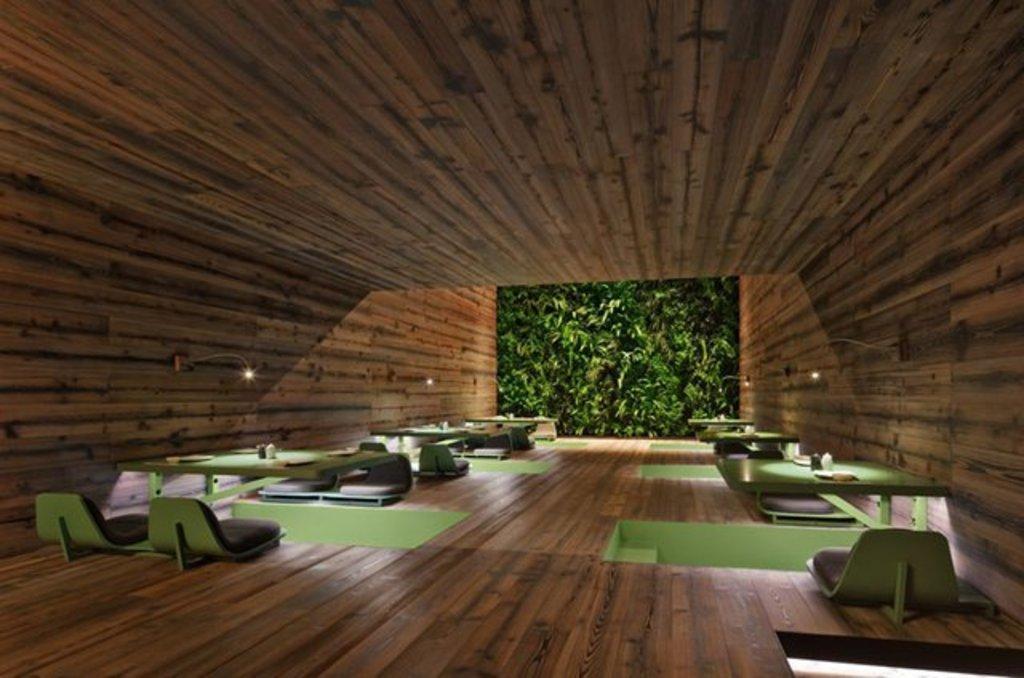How would you summarize this image in a sentence or two? In this image we can see tables and chairs. At the top there is roof. On the left there are lights attached to the wall. In the center we can see a screen. 